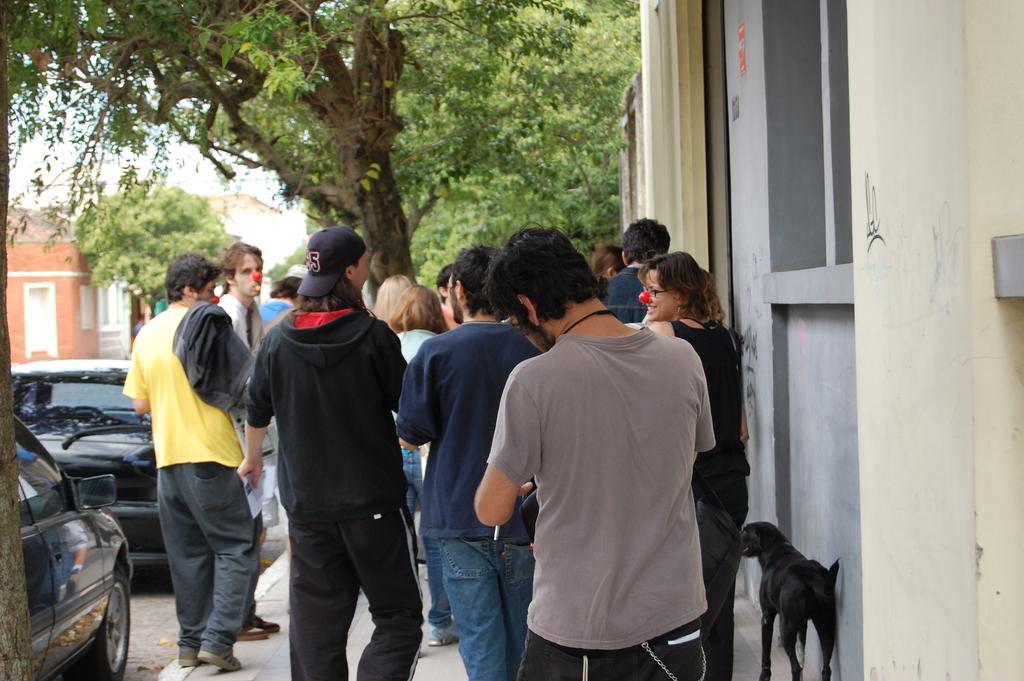How would you summarize this image in a sentence or two? In the picture there are few people on the footpath and on the right side there is a dog, there are some vehicles parked beside the footpath and in the background there are many trees and on the left side there is a house. 